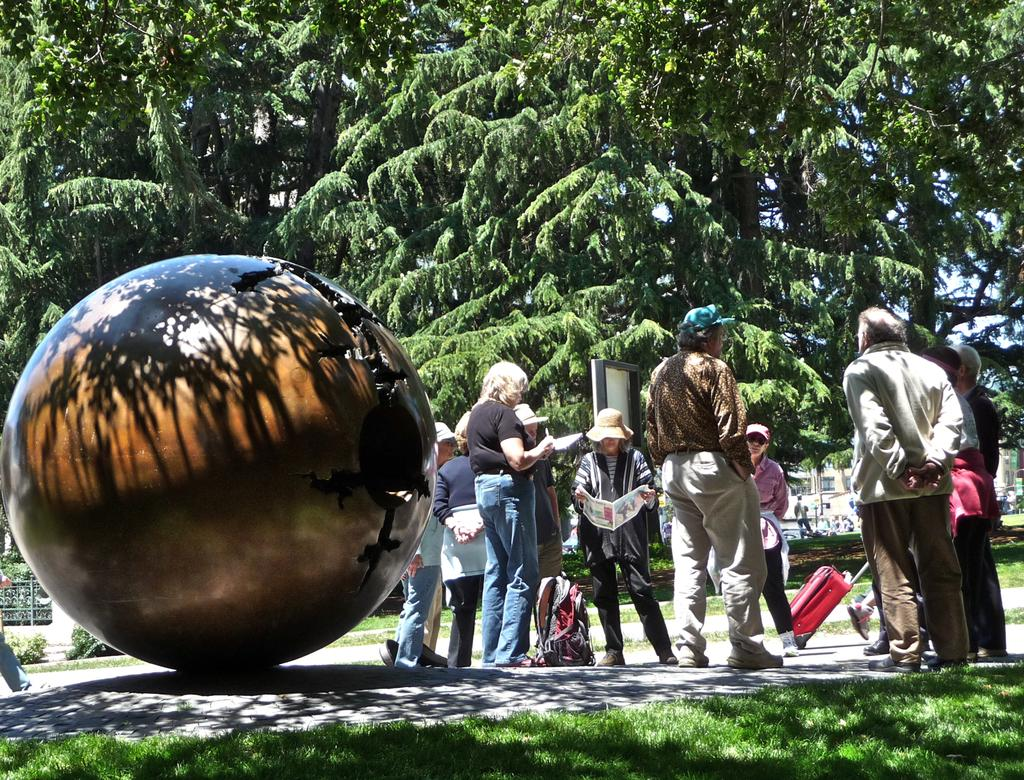What are the people in the image doing? The people in the image are walking and holding luggage. Are there any people standing still in the image? Yes, there are people standing in the image. What type of vegetation can be seen in the image? There are trees in the image. What is the ground made of in the image? The ground is made of grass in the image. What sound do the bells make in the image? There are no bells present in the image. Can you describe the eye color of the people in the image? The image does not provide enough detail to determine the eye color of the people. 